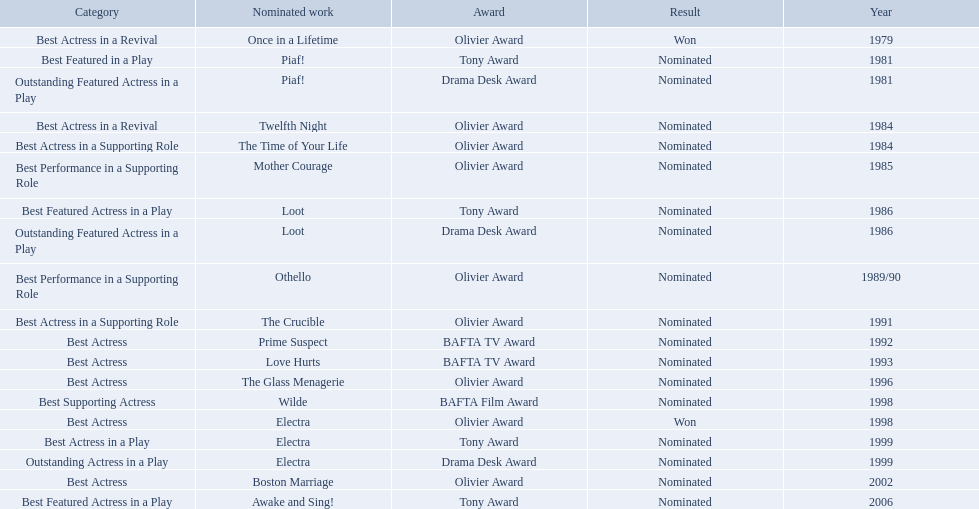What were all of the nominated works with zoe wanamaker? Once in a Lifetime, Piaf!, Piaf!, Twelfth Night, The Time of Your Life, Mother Courage, Loot, Loot, Othello, The Crucible, Prime Suspect, Love Hurts, The Glass Menagerie, Wilde, Electra, Electra, Electra, Boston Marriage, Awake and Sing!. And in which years were these nominations? 1979, 1981, 1981, 1984, 1984, 1985, 1986, 1986, 1989/90, 1991, 1992, 1993, 1996, 1998, 1998, 1999, 1999, 2002, 2006. Which categories was she nominated for in 1984? Best Actress in a Revival. And for which work was this nomination? Twelfth Night. What play was wanamaker nominated outstanding featured actress in a play? Piaf!. What year was wanamaker in once in a lifetime play? 1979. What play in 1984 was wanamaker nominated best actress? Twelfth Night. 